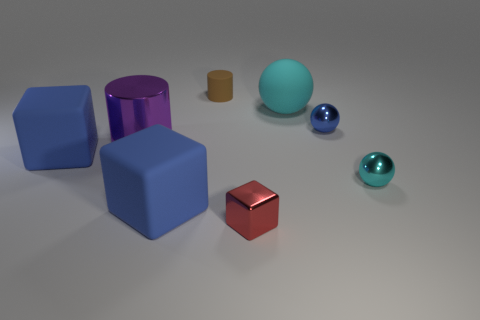What color is the small thing that is both in front of the tiny brown thing and behind the large cylinder?
Keep it short and to the point. Blue. Is the size of the cyan object that is in front of the blue metal ball the same as the small cylinder?
Keep it short and to the point. Yes. How many things are either shiny objects that are behind the red cube or tiny red rubber things?
Ensure brevity in your answer.  3. Are there any red objects of the same size as the cyan metal object?
Your answer should be compact. Yes. There is a purple object that is the same size as the cyan matte ball; what material is it?
Offer a terse response. Metal. The big thing that is right of the large purple shiny object and to the left of the tiny cylinder has what shape?
Provide a short and direct response. Cube. What is the color of the cube that is to the left of the big cylinder?
Provide a succinct answer. Blue. There is a object that is both in front of the purple metal cylinder and right of the cyan rubber object; how big is it?
Your answer should be very brief. Small. Do the purple cylinder and the cube that is on the right side of the tiny brown matte object have the same material?
Offer a very short reply. Yes. What number of big cyan matte things are the same shape as the brown rubber object?
Provide a succinct answer. 0. 